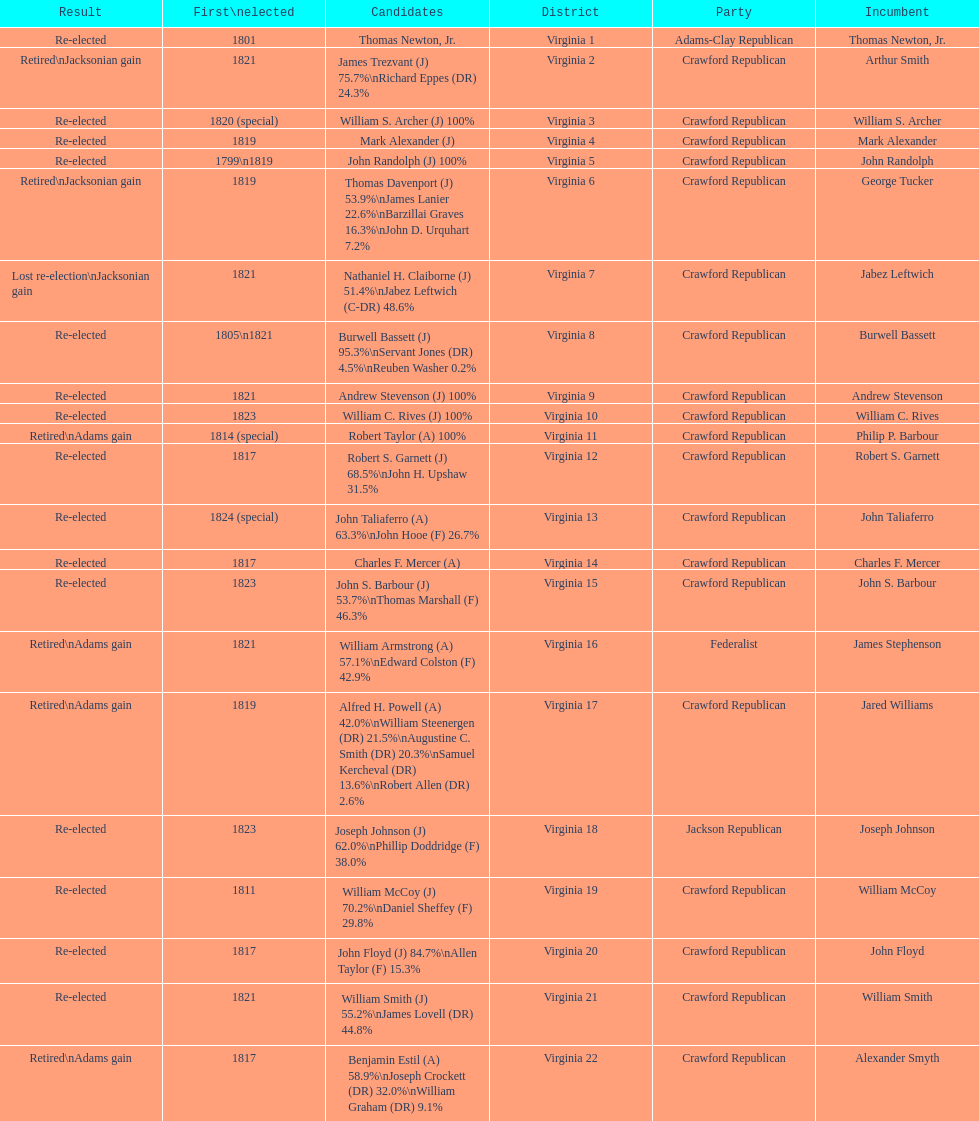How many candidates were there for virginia 17 district? 5. 